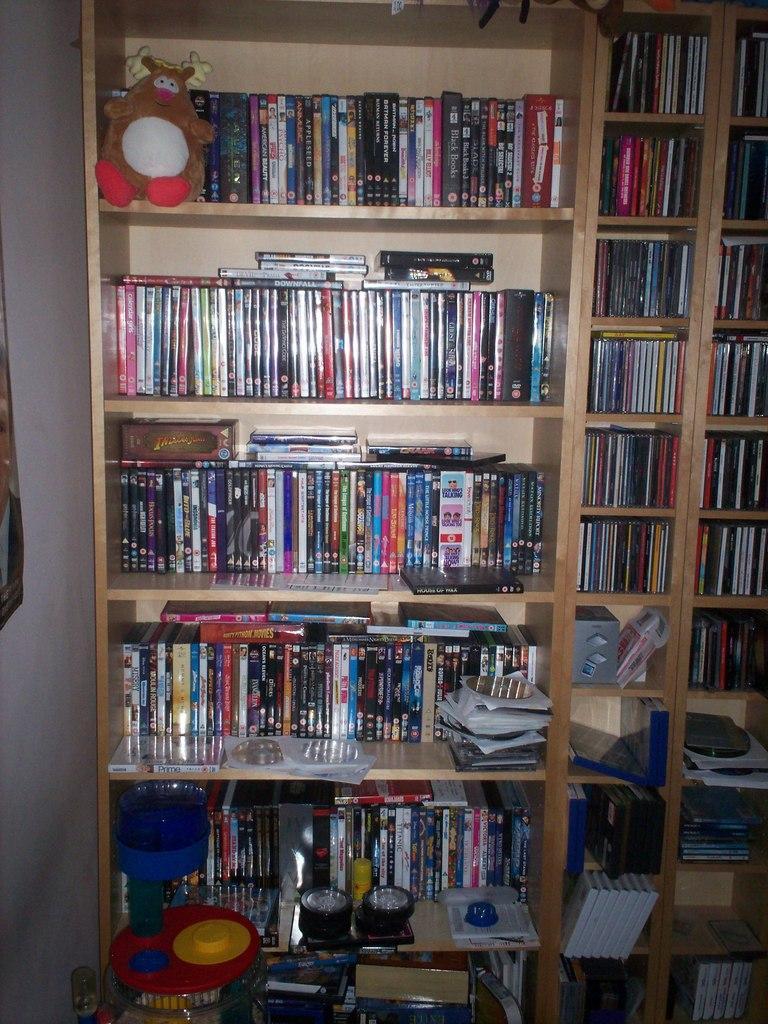How would you summarize this image in a sentence or two? In this image there are books, toys , CD's and some objects in the book shelves. 